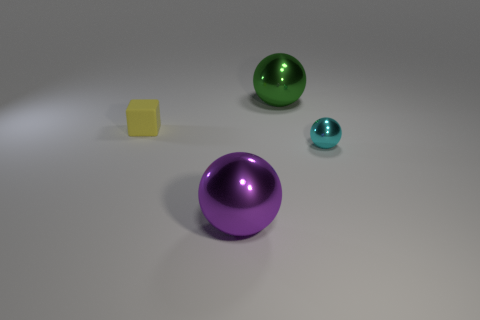What color is the tiny thing that is on the right side of the big thing behind the matte object?
Ensure brevity in your answer.  Cyan. Are there fewer yellow matte things than small purple rubber cubes?
Offer a terse response. No. Is there a large green object made of the same material as the yellow cube?
Provide a short and direct response. No. There is a small yellow thing; is it the same shape as the large metallic object that is on the right side of the purple shiny ball?
Give a very brief answer. No. Are there any big metallic things behind the large green metallic thing?
Your response must be concise. No. How many small yellow objects have the same shape as the tiny cyan thing?
Ensure brevity in your answer.  0. Is the large green ball made of the same material as the large thing in front of the tiny cyan metallic sphere?
Your answer should be very brief. Yes. What number of big cyan shiny blocks are there?
Provide a short and direct response. 0. There is a metallic thing that is right of the big green thing; how big is it?
Provide a succinct answer. Small. What number of other rubber cubes have the same size as the yellow cube?
Ensure brevity in your answer.  0. 